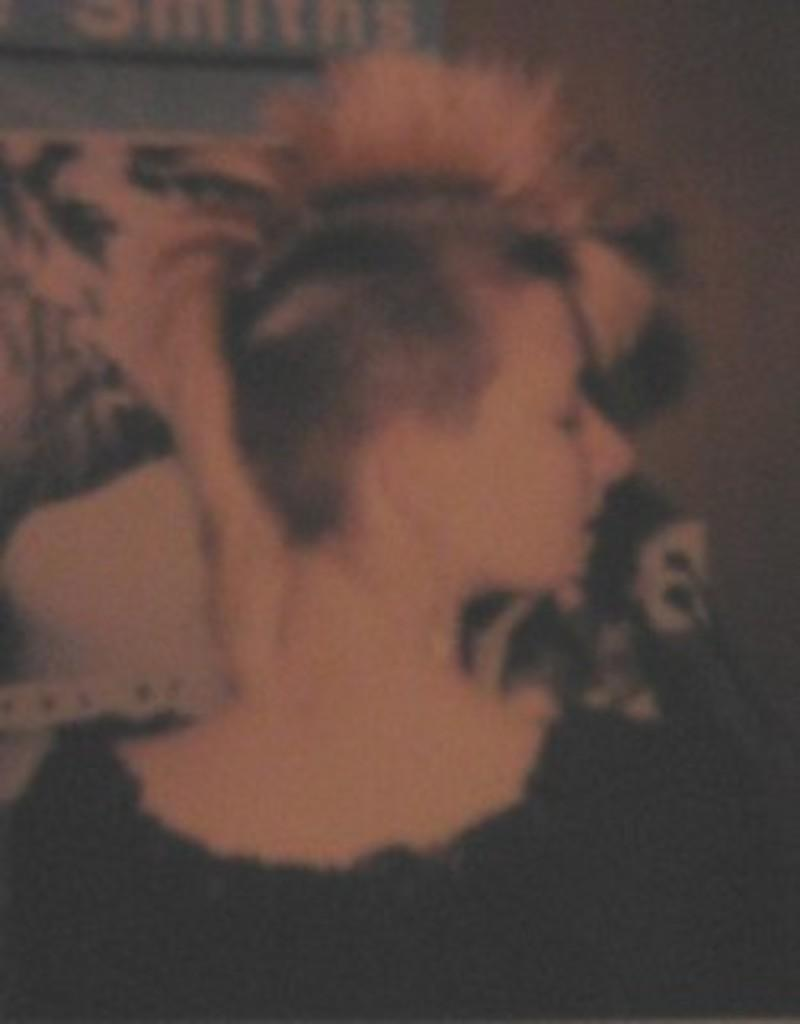What is the main subject of the image? There is a person in the image. What is the person wearing? The person is wearing a black dress. Can you describe the background of the image? The background of the image is blurred. What type of haircut does the person have in the image? There is no information about the person's haircut in the image. What brand of toothbrush is the person using in the image? There is no toothbrush present in the image. 